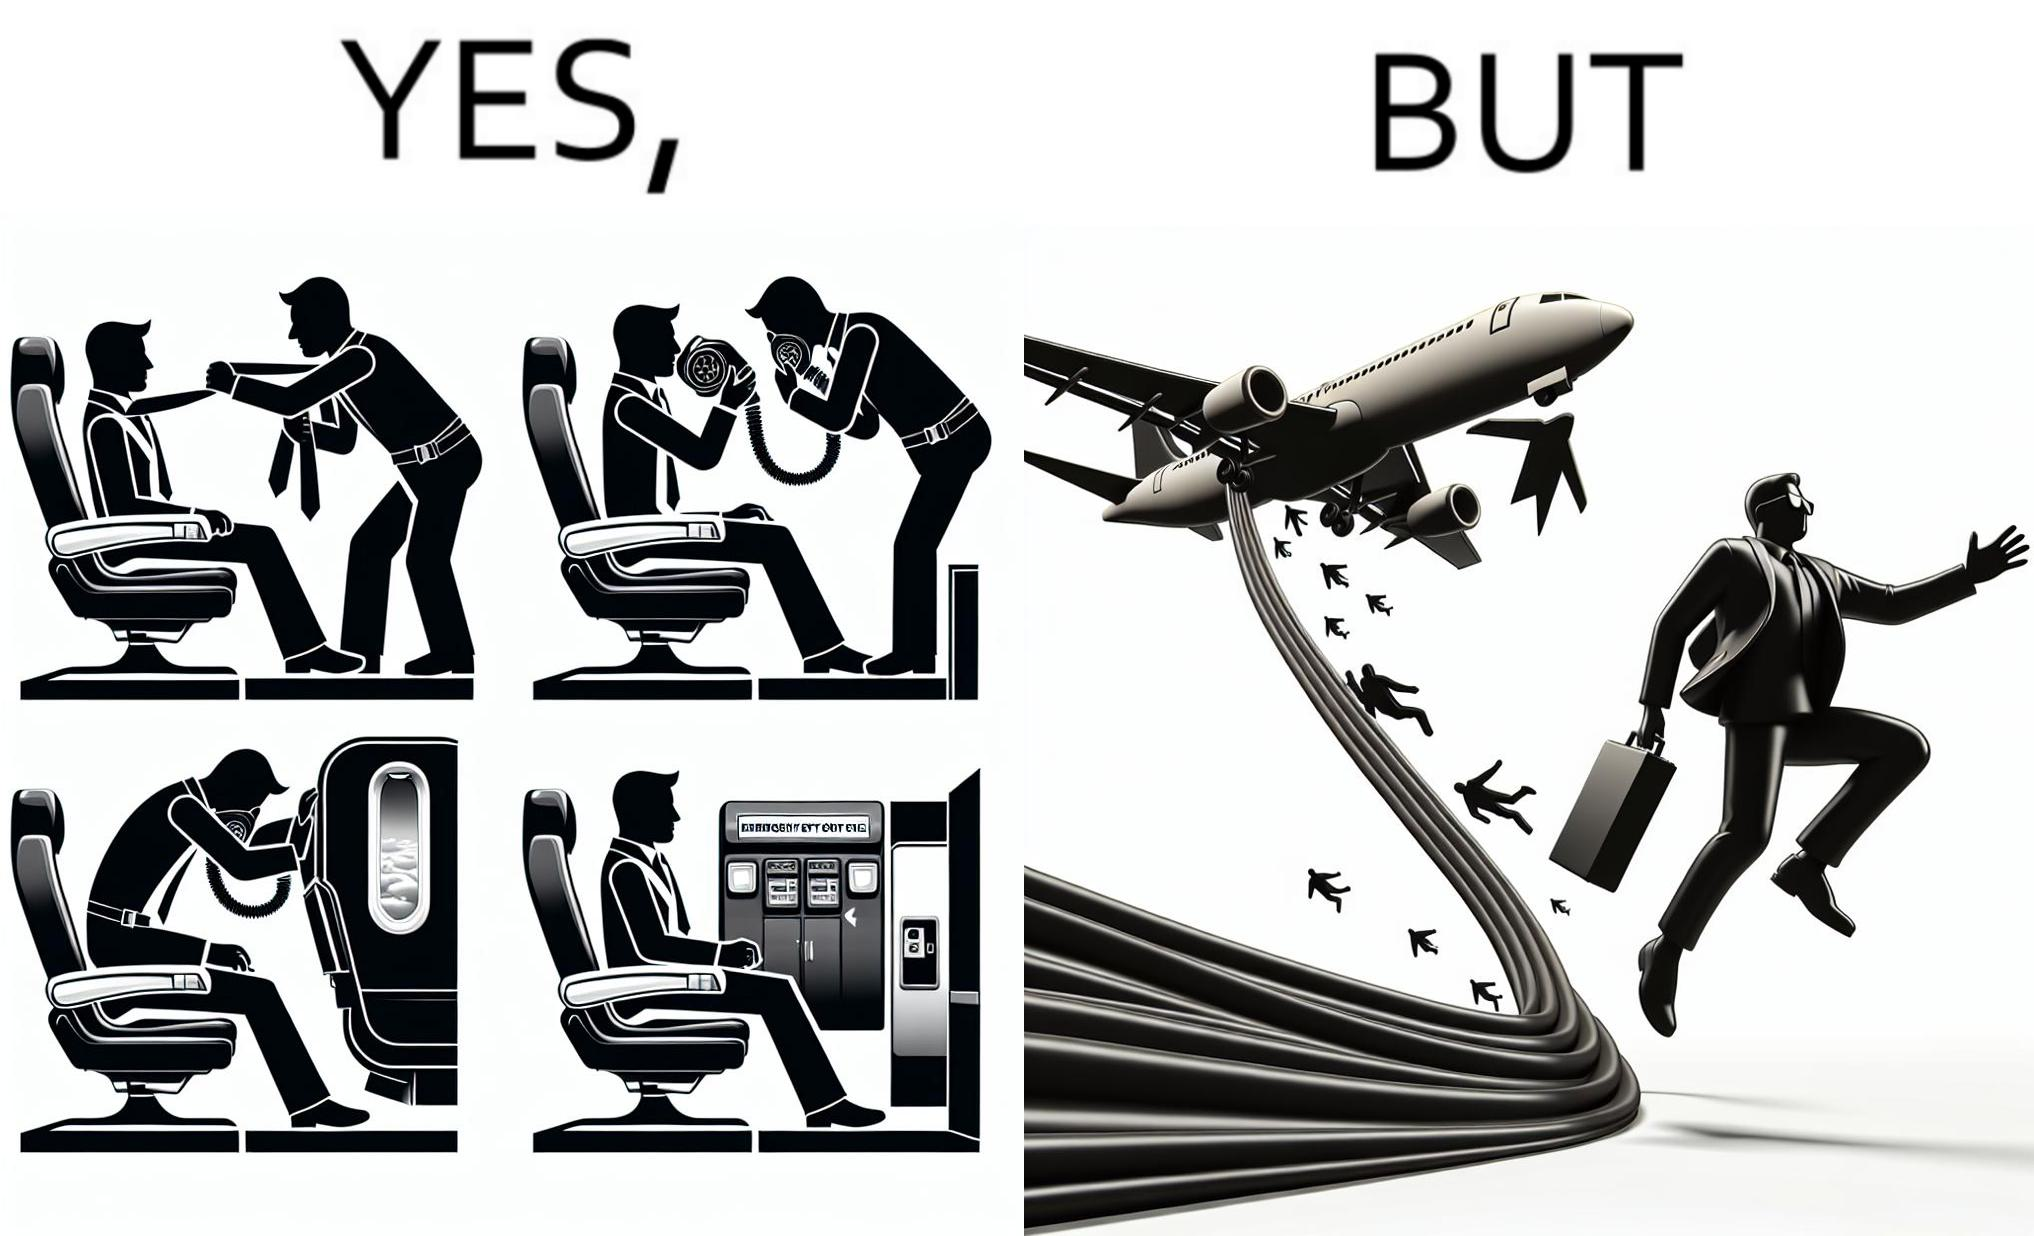Provide a description of this image. These images are funny since it shows how we are taught emergency procedures to follow in case of an accident while in an airplane but how none of them work if the plane is still in air 